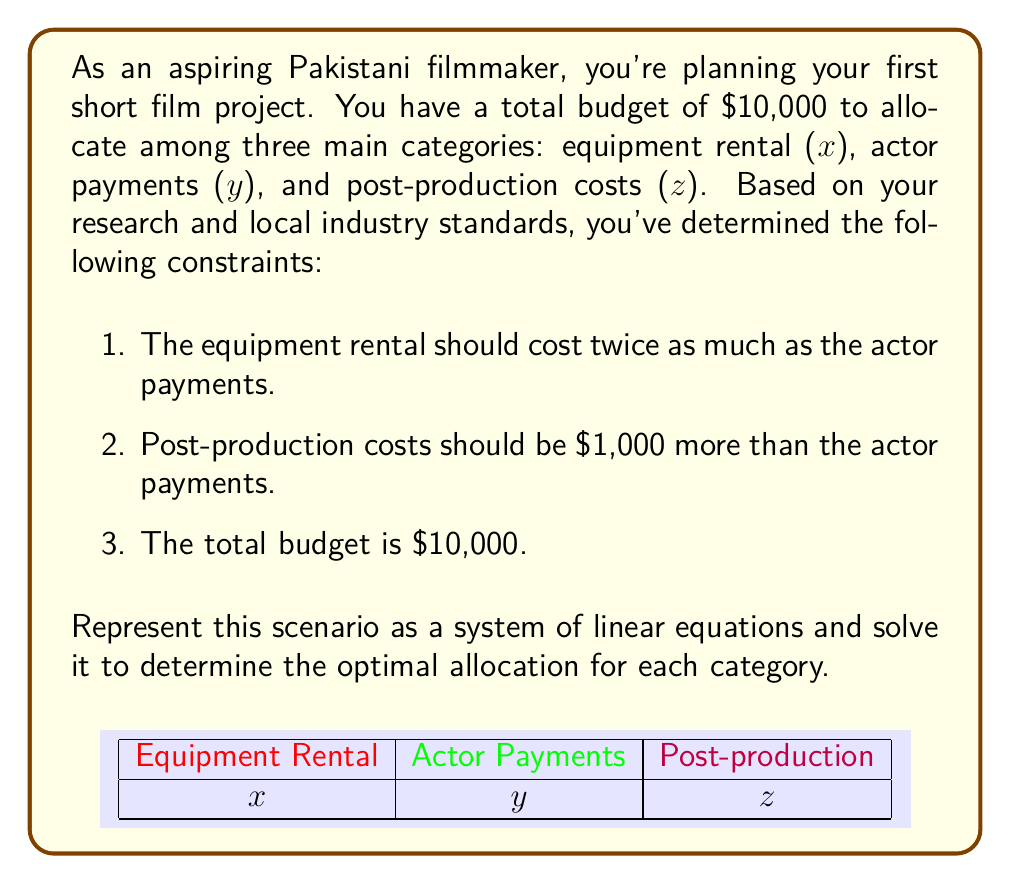Teach me how to tackle this problem. Let's approach this step-by-step:

1) First, let's translate the given information into a system of linear equations:

   $$\begin{cases}
   x = 2y & \text{(equipment rental is twice actor payments)}\\
   z = y + 1000 & \text{(post-production is $1000 more than actor payments)}\\
   x + y + z = 10000 & \text{(total budget constraint)}
   \end{cases}$$

2) We can solve this system by substitution. Let's start by substituting the expressions for x and z into the third equation:

   $$(2y) + y + (y + 1000) = 10000$$

3) Simplify:

   $$4y + 1000 = 10000$$

4) Subtract 1000 from both sides:

   $$4y = 9000$$

5) Divide both sides by 4:

   $$y = 2250$$

6) Now that we know y, we can find x and z:

   $$x = 2y = 2(2250) = 4500$$
   $$z = y + 1000 = 2250 + 1000 = 3250$$

7) Let's verify that these values satisfy the total budget constraint:

   $$4500 + 2250 + 3250 = 10000$$

Therefore, the optimal allocation is:
- Equipment rental (x): $4500
- Actor payments (y): $2250
- Post-production costs (z): $3250
Answer: x = $4500, y = $2250, z = $3250 